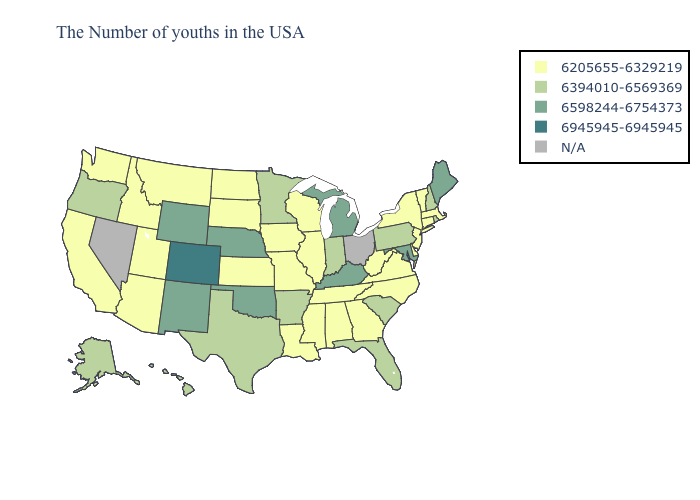Among the states that border North Carolina , does Tennessee have the lowest value?
Keep it brief. Yes. What is the value of North Carolina?
Keep it brief. 6205655-6329219. Name the states that have a value in the range N/A?
Write a very short answer. Ohio, Nevada. Does Michigan have the lowest value in the MidWest?
Short answer required. No. What is the value of Kansas?
Quick response, please. 6205655-6329219. Does the map have missing data?
Write a very short answer. Yes. What is the value of South Carolina?
Keep it brief. 6394010-6569369. What is the value of Utah?
Be succinct. 6205655-6329219. What is the value of Nevada?
Keep it brief. N/A. Name the states that have a value in the range 6205655-6329219?
Short answer required. Massachusetts, Vermont, Connecticut, New York, New Jersey, Delaware, Virginia, North Carolina, West Virginia, Georgia, Alabama, Tennessee, Wisconsin, Illinois, Mississippi, Louisiana, Missouri, Iowa, Kansas, South Dakota, North Dakota, Utah, Montana, Arizona, Idaho, California, Washington. What is the highest value in the MidWest ?
Keep it brief. 6598244-6754373. Name the states that have a value in the range N/A?
Short answer required. Ohio, Nevada. What is the value of Tennessee?
Be succinct. 6205655-6329219. What is the value of Ohio?
Concise answer only. N/A. Does the map have missing data?
Keep it brief. Yes. 